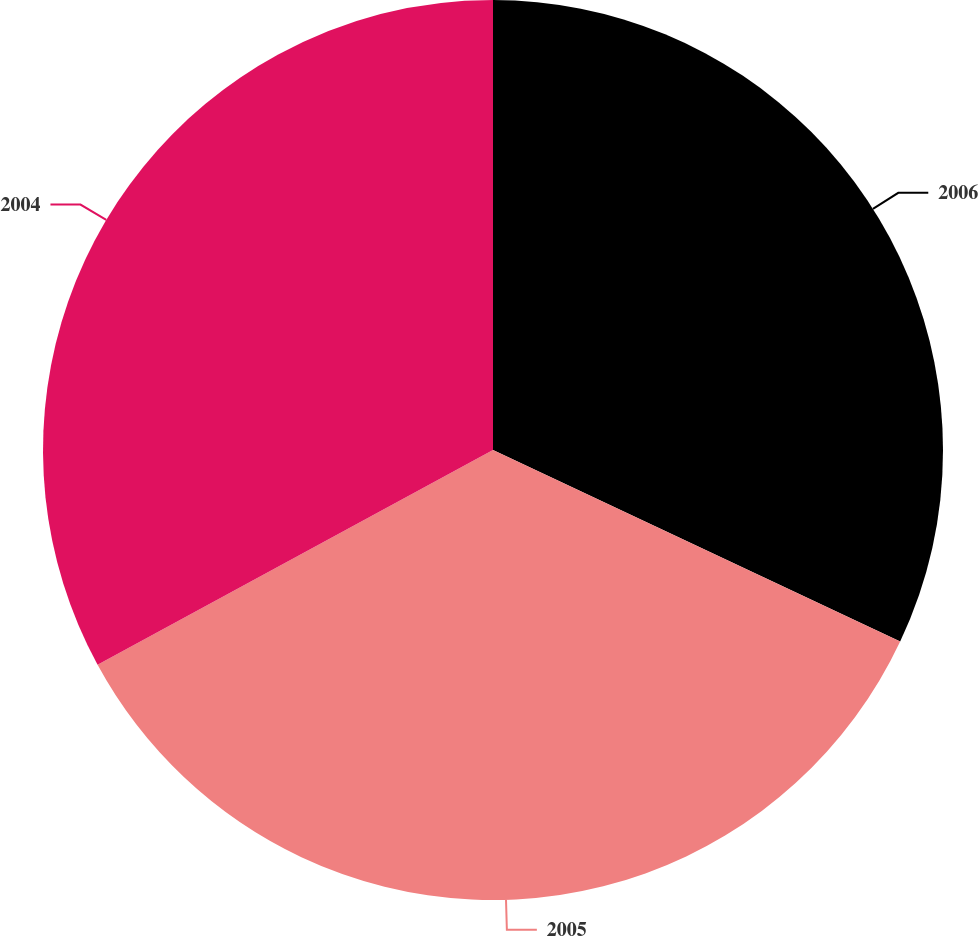<chart> <loc_0><loc_0><loc_500><loc_500><pie_chart><fcel>2006<fcel>2005<fcel>2004<nl><fcel>32.0%<fcel>35.08%<fcel>32.92%<nl></chart> 